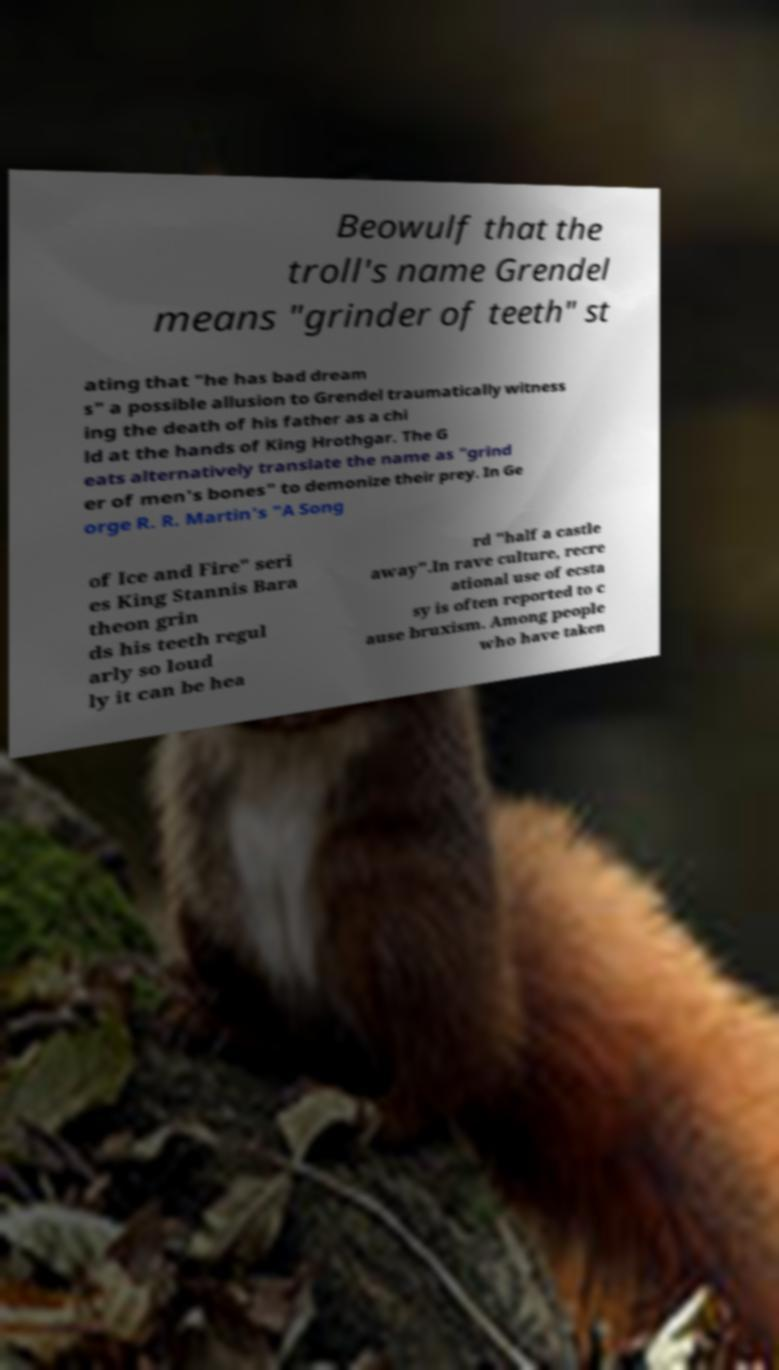Please identify and transcribe the text found in this image. Beowulf that the troll's name Grendel means "grinder of teeth" st ating that "he has bad dream s" a possible allusion to Grendel traumatically witness ing the death of his father as a chi ld at the hands of King Hrothgar. The G eats alternatively translate the name as "grind er of men's bones" to demonize their prey. In Ge orge R. R. Martin's "A Song of Ice and Fire" seri es King Stannis Bara theon grin ds his teeth regul arly so loud ly it can be hea rd "half a castle away".In rave culture, recre ational use of ecsta sy is often reported to c ause bruxism. Among people who have taken 